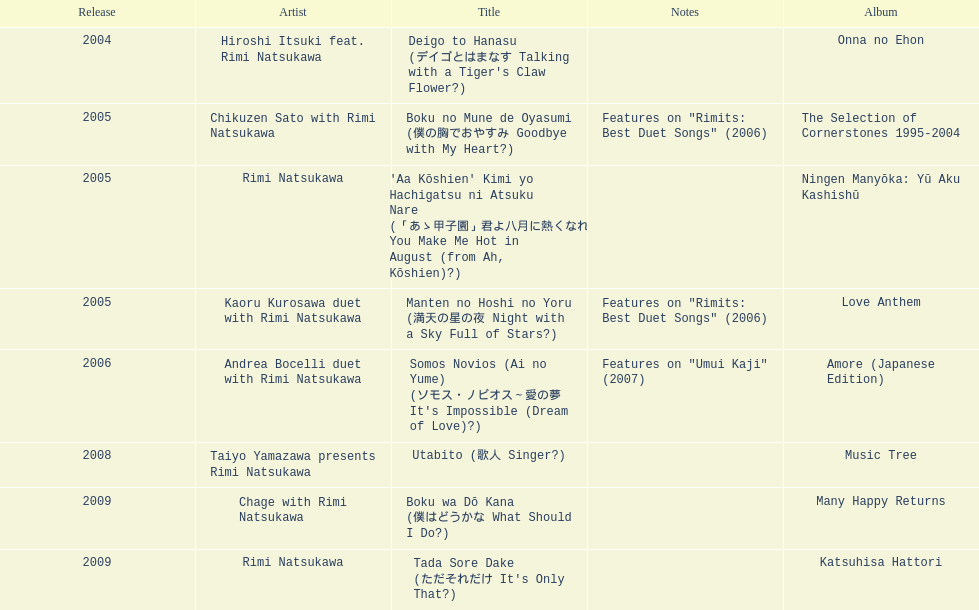Between deigo to hanasu and utabito, which was released earlier? Deigo to Hanasu. 